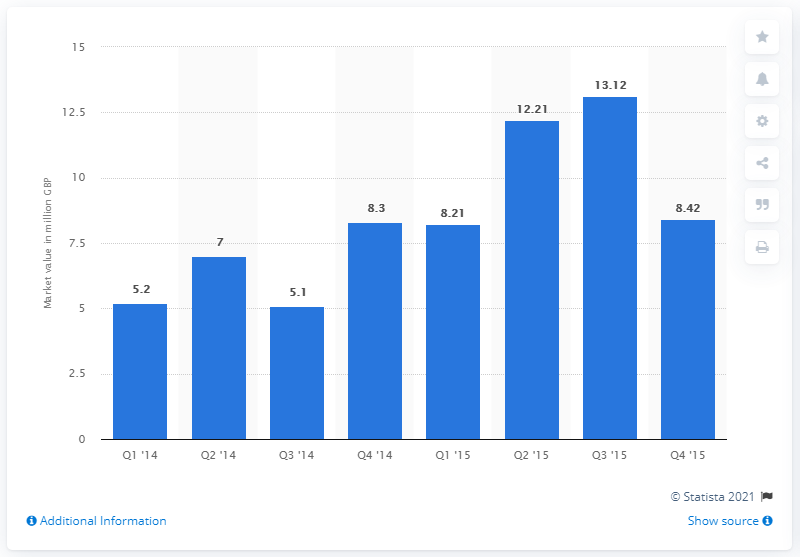Specify some key components in this picture. The reward-based crowdfunding market had a value of approximately 13.12 in the third quarter of 2015. The reward-based crowdfunding market had a value of approximately $5.1 billion in the third quarter of 2014. 